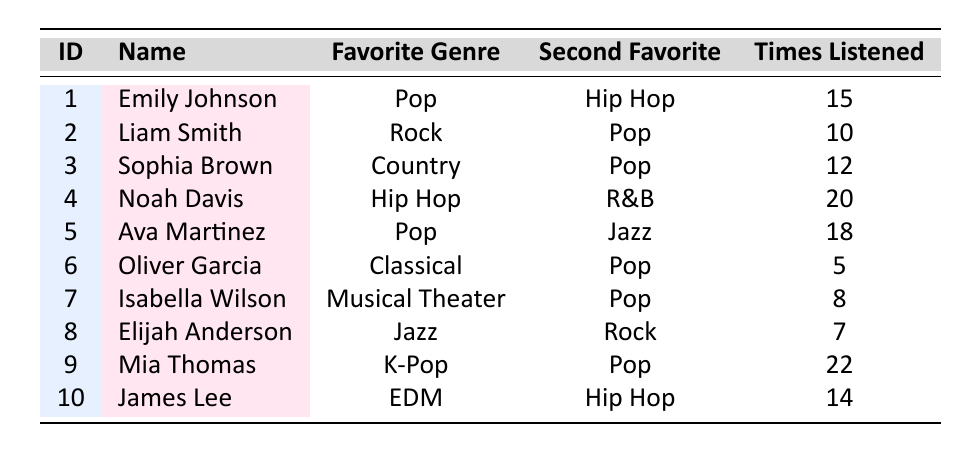What is the favorite genre of Mia Thomas? According to the table, Mia Thomas has "K-Pop" listed as her favorite genre.
Answer: K-Pop How many times did Noah Davis listen to music this month? The table shows that Noah Davis listened to music 20 times this month.
Answer: 20 Which student has the second favorite genre of R&B? The table indicates that Noah Davis has R&B as his second favorite genre.
Answer: Noah Davis What is the average number of times students listened to music this month? To find the average, we add all the "Times Listened This Month" values: 15 + 10 + 12 + 20 + 18 + 5 + 8 + 7 + 22 + 14 =  132. There are 10 students, so the average is 132 / 10 = 13.2.
Answer: 13.2 Which genre is favored by the most students as their favorite genre? Counting the "Favorite Genre" column, "Pop" appears 4 times, "Hip Hop" 2 times, and the others once. Thus, the most favored genre is "Pop."
Answer: Pop Is it true that any student has Classical as their favorite genre? Reviewing the table, Oliver Garcia has "Classical" as his favorite genre, which confirms that it is true.
Answer: Yes How many students prefer Pop as either their favorite or second favorite genre? Checking the table: Emily Johnson, Ava Martinez, Noah Davis, Sophia Brown, and Mia Thomas have "Pop" as their favorite or second favorite genre, totaling 5 students.
Answer: 5 What is the difference between the student who listened the most this month and the one who listened the least? Mia Thomas listened 22 times, and Oliver Garcia listened 5 times. The difference is 22 - 5 = 17.
Answer: 17 Which student has the highest number of times listened to music this month, and what is that number? Mia Thomas has the highest number of listens at 22 times this month according to the table data.
Answer: Mia Thomas, 22 